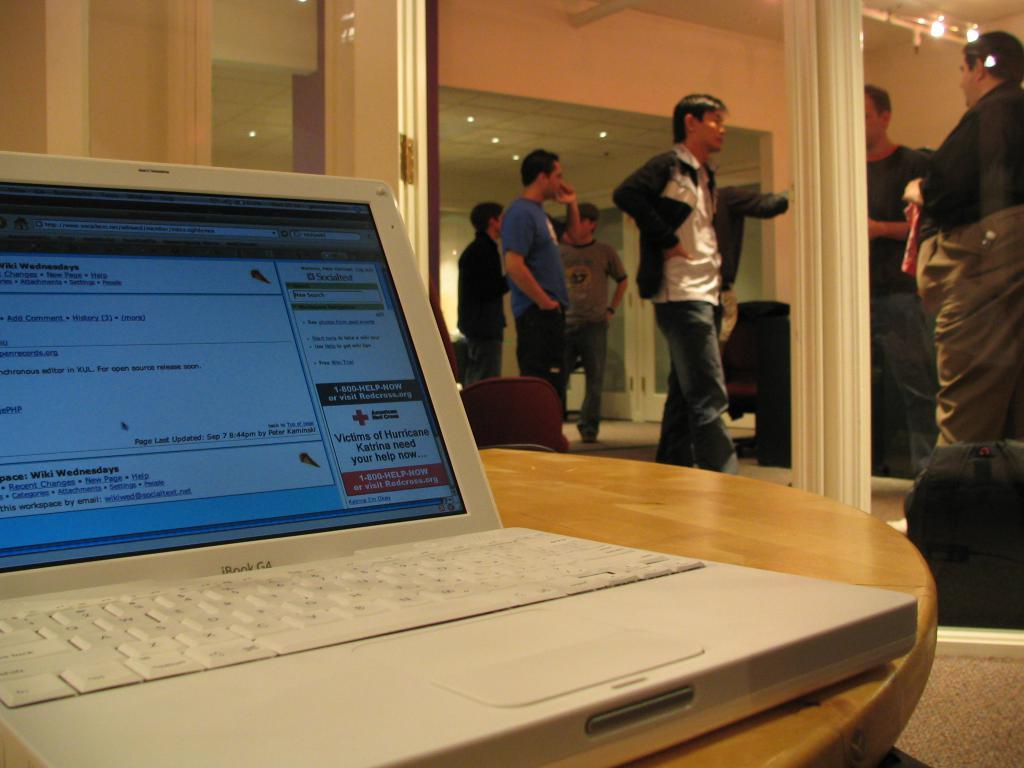Who or what can be seen in the image? There are people in the image. What can be seen illuminating the scene? There are lights in the image. What piece of furniture is present in the image? There is a table in the image. What electronic device is visible in the image? There is a laptop in the image. What is displayed on the laptop screen? Something is written on the laptop screen. What else can be observed in the image besides the people, lights, table, and laptop? There are objects in the image. Can you describe the zebra that is walking towards the people in the image? There is no zebra present in the image. What part of the stranger's body can be seen in the image? There is no stranger present in the image. 